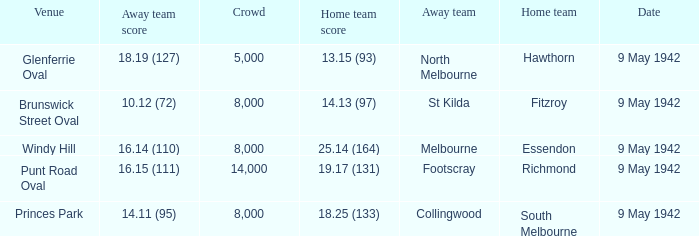How many people attended the game where Footscray was away? 14000.0. 